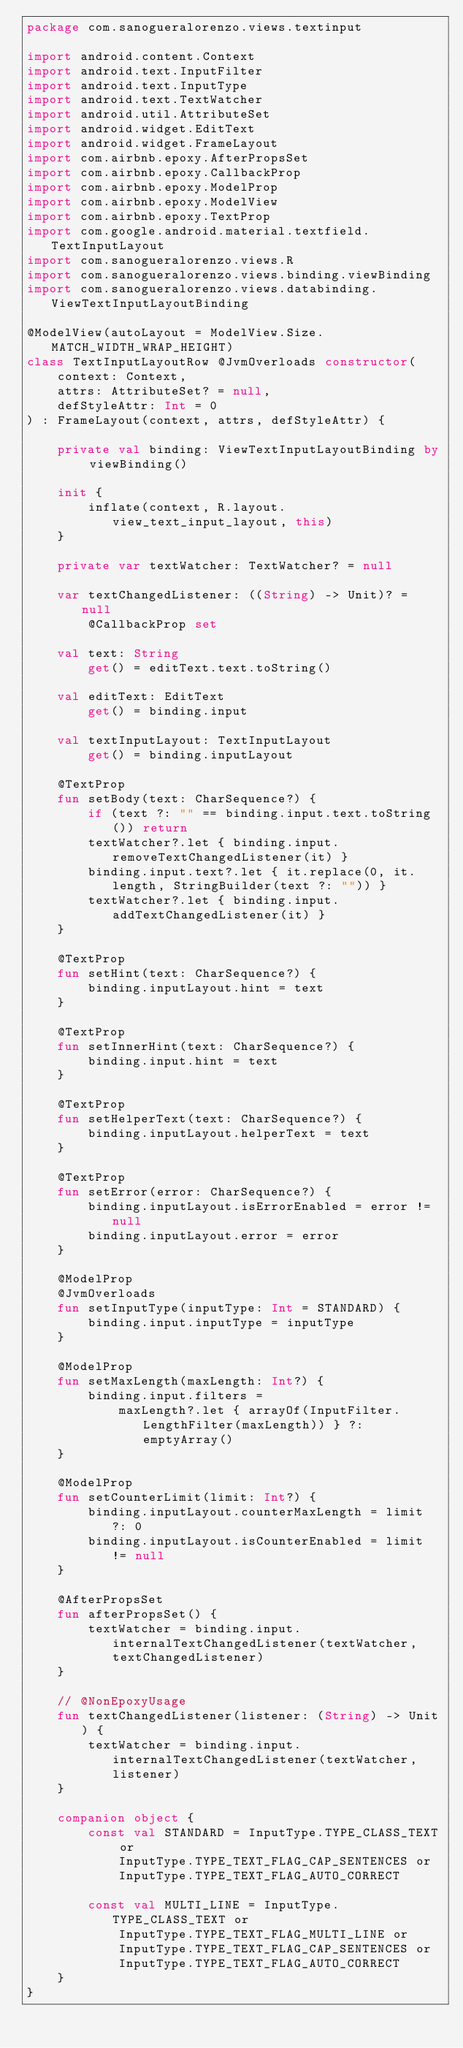<code> <loc_0><loc_0><loc_500><loc_500><_Kotlin_>package com.sanogueralorenzo.views.textinput

import android.content.Context
import android.text.InputFilter
import android.text.InputType
import android.text.TextWatcher
import android.util.AttributeSet
import android.widget.EditText
import android.widget.FrameLayout
import com.airbnb.epoxy.AfterPropsSet
import com.airbnb.epoxy.CallbackProp
import com.airbnb.epoxy.ModelProp
import com.airbnb.epoxy.ModelView
import com.airbnb.epoxy.TextProp
import com.google.android.material.textfield.TextInputLayout
import com.sanogueralorenzo.views.R
import com.sanogueralorenzo.views.binding.viewBinding
import com.sanogueralorenzo.views.databinding.ViewTextInputLayoutBinding

@ModelView(autoLayout = ModelView.Size.MATCH_WIDTH_WRAP_HEIGHT)
class TextInputLayoutRow @JvmOverloads constructor(
    context: Context,
    attrs: AttributeSet? = null,
    defStyleAttr: Int = 0
) : FrameLayout(context, attrs, defStyleAttr) {

    private val binding: ViewTextInputLayoutBinding by viewBinding()

    init {
        inflate(context, R.layout.view_text_input_layout, this)
    }

    private var textWatcher: TextWatcher? = null

    var textChangedListener: ((String) -> Unit)? = null
        @CallbackProp set

    val text: String
        get() = editText.text.toString()

    val editText: EditText
        get() = binding.input

    val textInputLayout: TextInputLayout
        get() = binding.inputLayout

    @TextProp
    fun setBody(text: CharSequence?) {
        if (text ?: "" == binding.input.text.toString()) return
        textWatcher?.let { binding.input.removeTextChangedListener(it) }
        binding.input.text?.let { it.replace(0, it.length, StringBuilder(text ?: "")) }
        textWatcher?.let { binding.input.addTextChangedListener(it) }
    }

    @TextProp
    fun setHint(text: CharSequence?) {
        binding.inputLayout.hint = text
    }

    @TextProp
    fun setInnerHint(text: CharSequence?) {
        binding.input.hint = text
    }

    @TextProp
    fun setHelperText(text: CharSequence?) {
        binding.inputLayout.helperText = text
    }

    @TextProp
    fun setError(error: CharSequence?) {
        binding.inputLayout.isErrorEnabled = error != null
        binding.inputLayout.error = error
    }

    @ModelProp
    @JvmOverloads
    fun setInputType(inputType: Int = STANDARD) {
        binding.input.inputType = inputType
    }

    @ModelProp
    fun setMaxLength(maxLength: Int?) {
        binding.input.filters =
            maxLength?.let { arrayOf(InputFilter.LengthFilter(maxLength)) } ?: emptyArray()
    }

    @ModelProp
    fun setCounterLimit(limit: Int?) {
        binding.inputLayout.counterMaxLength = limit ?: 0
        binding.inputLayout.isCounterEnabled = limit != null
    }

    @AfterPropsSet
    fun afterPropsSet() {
        textWatcher = binding.input.internalTextChangedListener(textWatcher, textChangedListener)
    }

    // @NonEpoxyUsage
    fun textChangedListener(listener: (String) -> Unit) {
        textWatcher = binding.input.internalTextChangedListener(textWatcher, listener)
    }

    companion object {
        const val STANDARD = InputType.TYPE_CLASS_TEXT or
            InputType.TYPE_TEXT_FLAG_CAP_SENTENCES or
            InputType.TYPE_TEXT_FLAG_AUTO_CORRECT

        const val MULTI_LINE = InputType.TYPE_CLASS_TEXT or
            InputType.TYPE_TEXT_FLAG_MULTI_LINE or
            InputType.TYPE_TEXT_FLAG_CAP_SENTENCES or
            InputType.TYPE_TEXT_FLAG_AUTO_CORRECT
    }
}
</code> 